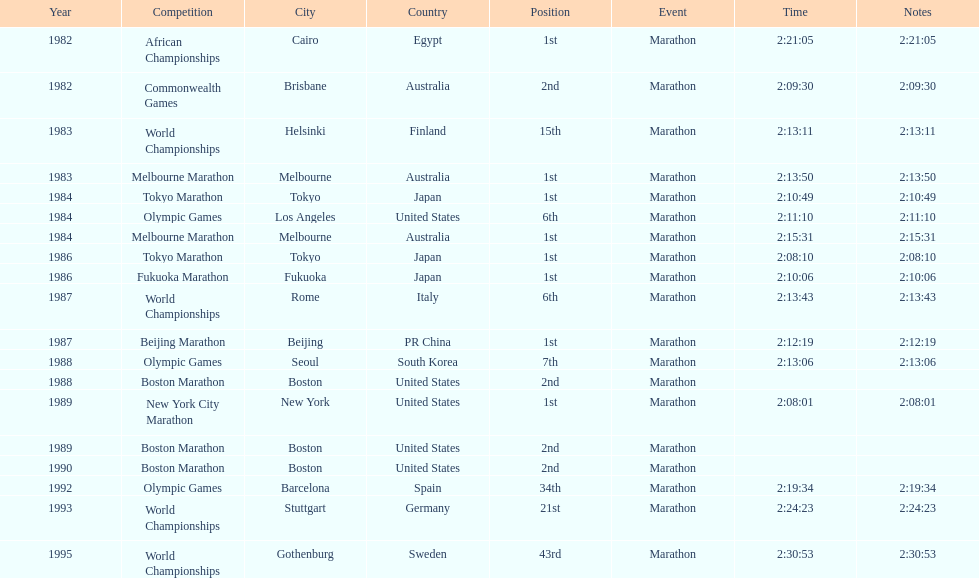How many times in total did ikangaa run the marathon in the olympic games? 3. 